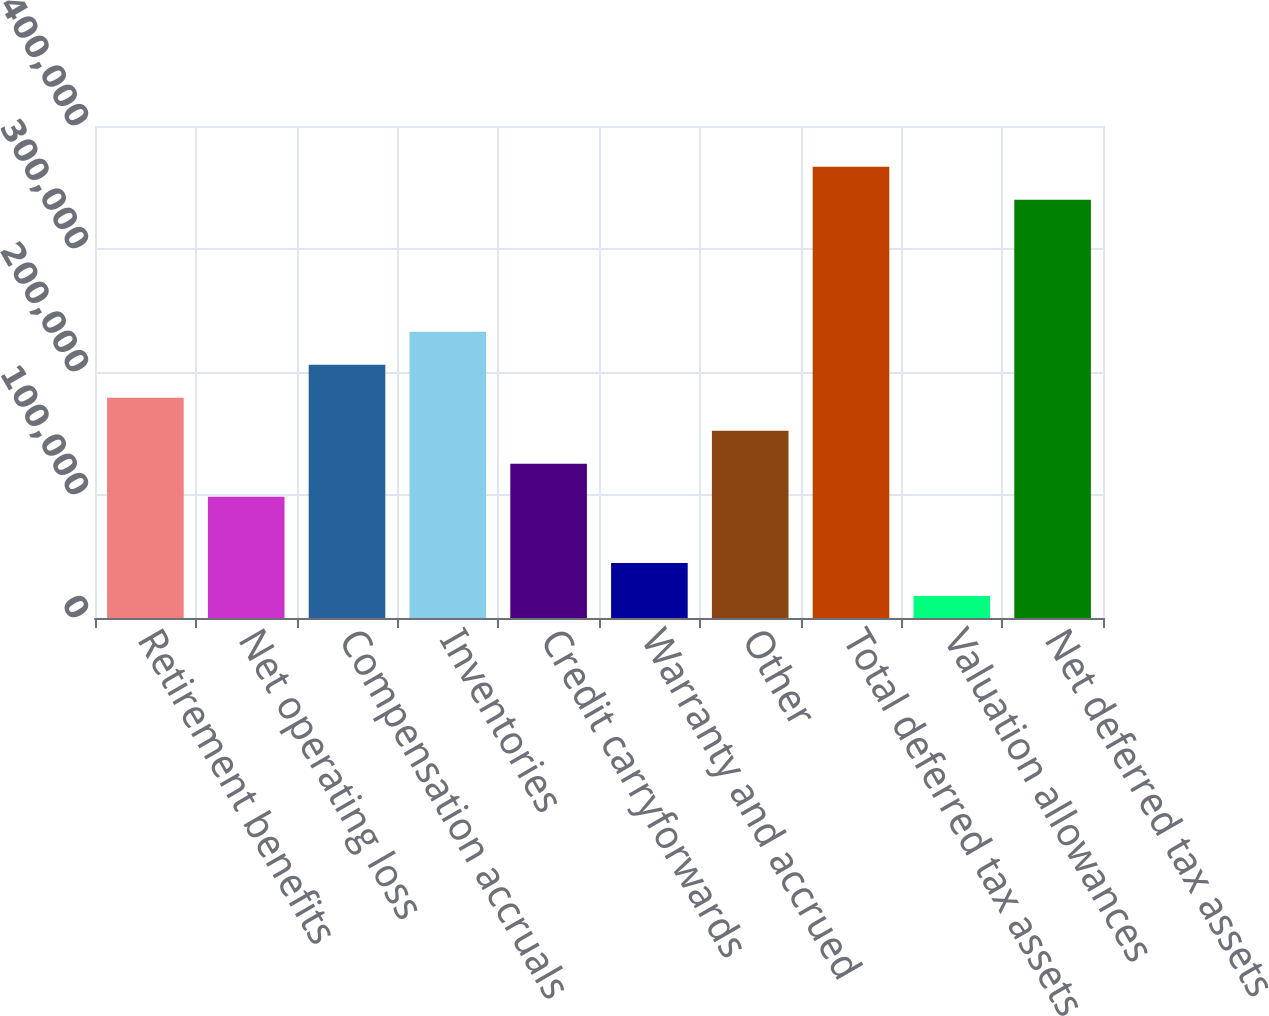<chart> <loc_0><loc_0><loc_500><loc_500><bar_chart><fcel>Retirement benefits<fcel>Net operating loss<fcel>Compensation accruals<fcel>Inventories<fcel>Credit carryforwards<fcel>Warranty and accrued<fcel>Other<fcel>Total deferred tax assets<fcel>Valuation allowances<fcel>Net deferred tax assets<nl><fcel>179023<fcel>98498.9<fcel>205864<fcel>232705<fcel>125340<fcel>44816.3<fcel>152182<fcel>366912<fcel>17975<fcel>340071<nl></chart> 